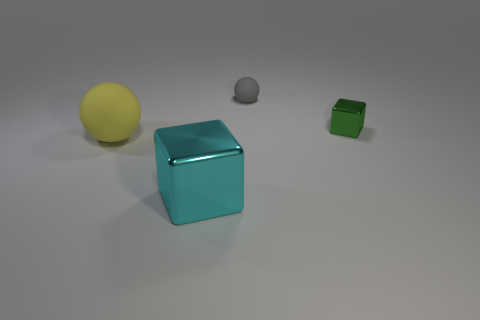Add 3 blue metal cylinders. How many objects exist? 7 Subtract 0 brown cylinders. How many objects are left? 4 Subtract all tiny green blocks. Subtract all large cyan shiny things. How many objects are left? 2 Add 1 gray rubber spheres. How many gray rubber spheres are left? 2 Add 1 gray balls. How many gray balls exist? 2 